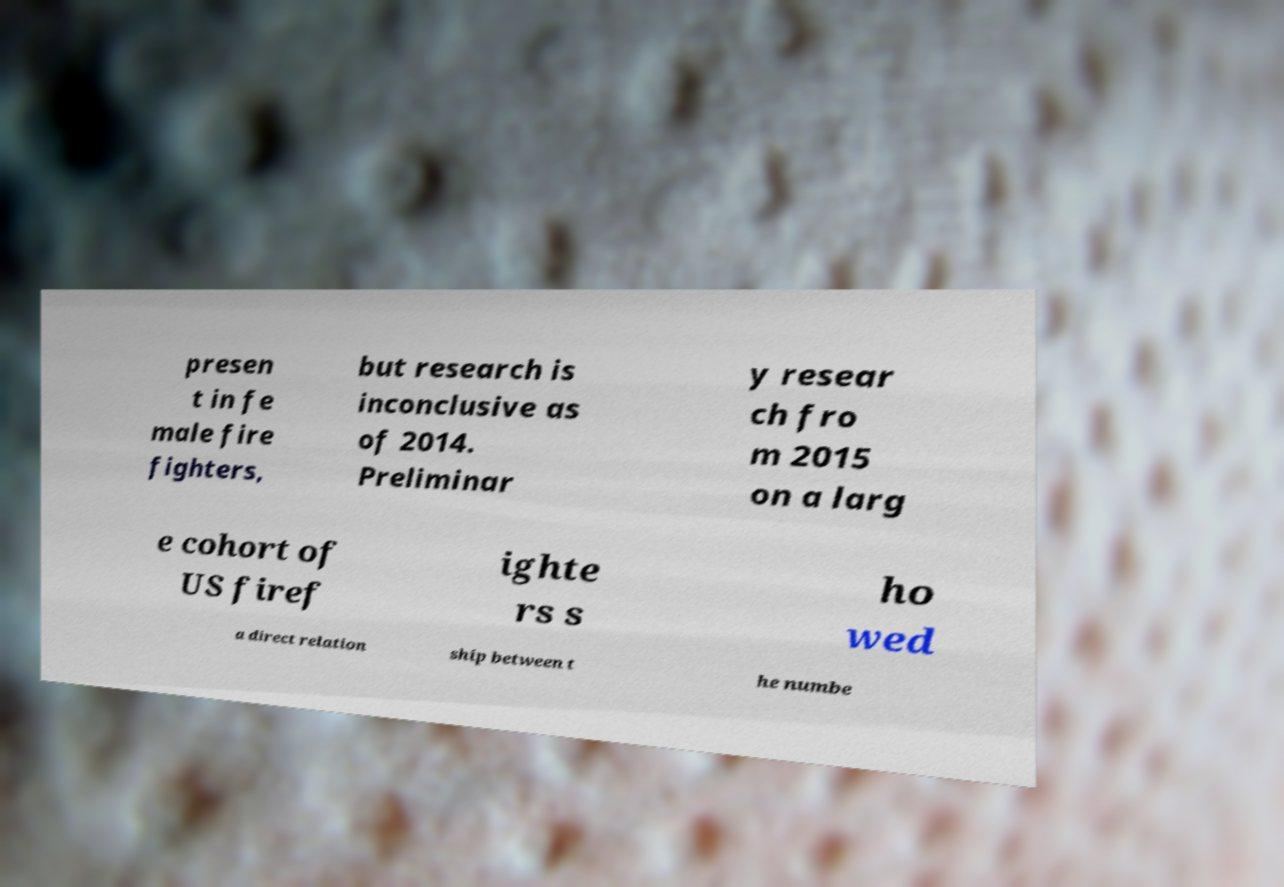Please read and relay the text visible in this image. What does it say? presen t in fe male fire fighters, but research is inconclusive as of 2014. Preliminar y resear ch fro m 2015 on a larg e cohort of US firef ighte rs s ho wed a direct relation ship between t he numbe 